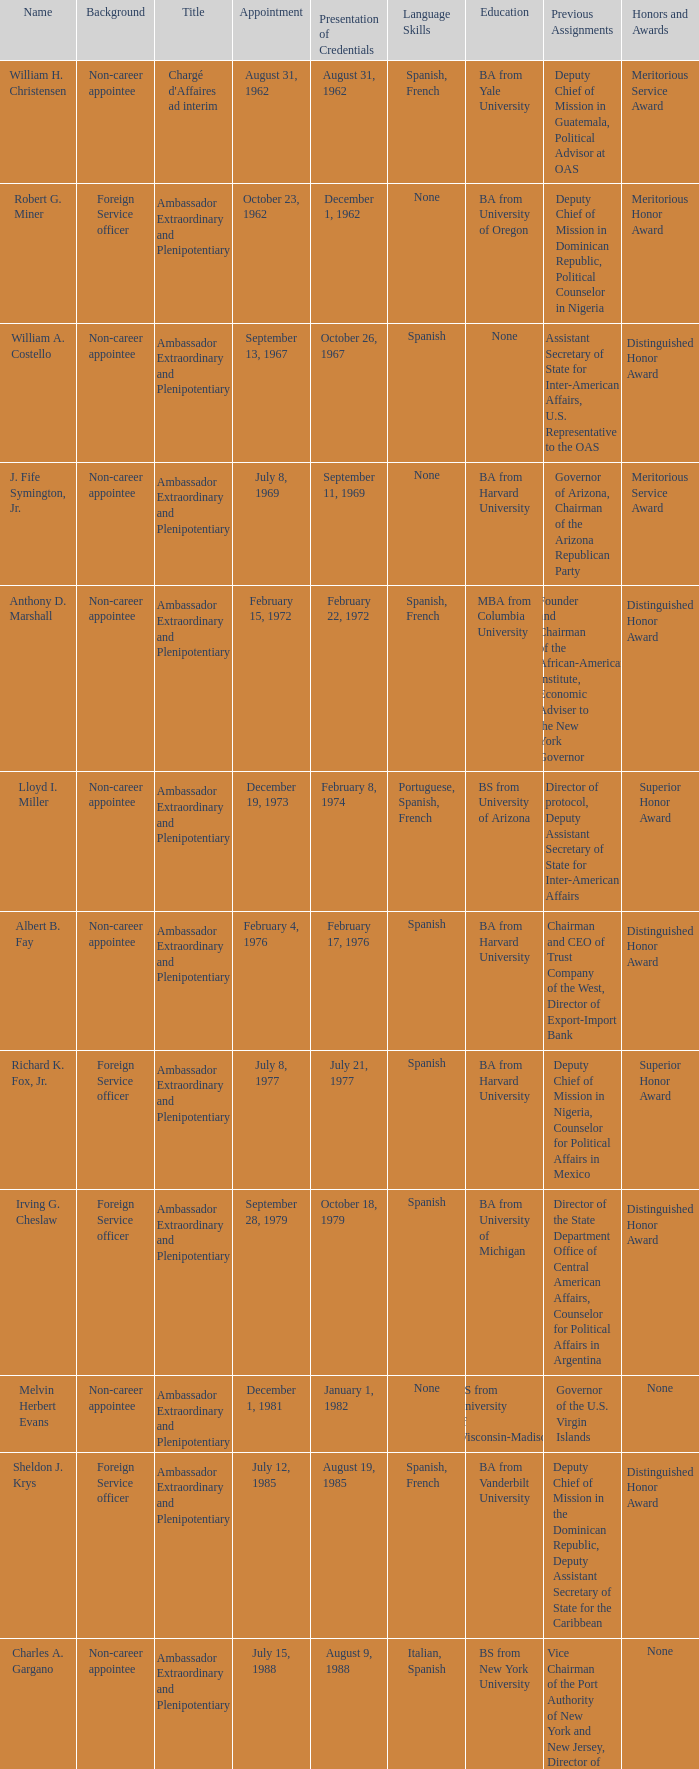Who presented their credentials at an unknown date? Margaret B. Diop. Would you mind parsing the complete table? {'header': ['Name', 'Background', 'Title', 'Appointment', 'Presentation of Credentials', 'Language Skills', 'Education', 'Previous Assignments', 'Honors and Awards'], 'rows': [['William H. Christensen', 'Non-career appointee', "Chargé d'Affaires ad interim", 'August 31, 1962', 'August 31, 1962', 'Spanish, French', 'BA from Yale University', 'Deputy Chief of Mission in Guatemala, Political Advisor at OAS', 'Meritorious Service Award'], ['Robert G. Miner', 'Foreign Service officer', 'Ambassador Extraordinary and Plenipotentiary', 'October 23, 1962', 'December 1, 1962', 'None', 'BA from University of Oregon', 'Deputy Chief of Mission in Dominican Republic, Political Counselor in Nigeria', 'Meritorious Honor Award'], ['William A. Costello', 'Non-career appointee', 'Ambassador Extraordinary and Plenipotentiary', 'September 13, 1967', 'October 26, 1967', 'Spanish', 'None', 'Assistant Secretary of State for Inter-American Affairs, U.S. Representative to the OAS', 'Distinguished Honor Award'], ['J. Fife Symington, Jr.', 'Non-career appointee', 'Ambassador Extraordinary and Plenipotentiary', 'July 8, 1969', 'September 11, 1969', 'None', 'BA from Harvard University', 'Governor of Arizona, Chairman of the Arizona Republican Party', 'Meritorious Service Award'], ['Anthony D. Marshall', 'Non-career appointee', 'Ambassador Extraordinary and Plenipotentiary', 'February 15, 1972', 'February 22, 1972', 'Spanish, French', 'MBA from Columbia University', 'Founder and Chairman of the African-American Institute, Economic Adviser to the New York Governor', 'Distinguished Honor Award'], ['Lloyd I. Miller', 'Non-career appointee', 'Ambassador Extraordinary and Plenipotentiary', 'December 19, 1973', 'February 8, 1974', 'Portuguese, Spanish, French', 'BS from University of Arizona', 'Director of protocol, Deputy Assistant Secretary of State for Inter-American Affairs', 'Superior Honor Award'], ['Albert B. Fay', 'Non-career appointee', 'Ambassador Extraordinary and Plenipotentiary', 'February 4, 1976', 'February 17, 1976', 'Spanish', 'BA from Harvard University', 'Chairman and CEO of Trust Company of the West, Director of Export-Import Bank', 'Distinguished Honor Award'], ['Richard K. Fox, Jr.', 'Foreign Service officer', 'Ambassador Extraordinary and Plenipotentiary', 'July 8, 1977', 'July 21, 1977', 'Spanish', 'BA from Harvard University', 'Deputy Chief of Mission in Nigeria, Counselor for Political Affairs in Mexico', 'Superior Honor Award'], ['Irving G. Cheslaw', 'Foreign Service officer', 'Ambassador Extraordinary and Plenipotentiary', 'September 28, 1979', 'October 18, 1979', 'Spanish', 'BA from University of Michigan', 'Director of the State Department Office of Central American Affairs, Counselor for Political Affairs in Argentina', 'Distinguished Honor Award'], ['Melvin Herbert Evans', 'Non-career appointee', 'Ambassador Extraordinary and Plenipotentiary', 'December 1, 1981', 'January 1, 1982', 'None', 'BS from University of Wisconsin-Madison', 'Governor of the U.S. Virgin Islands', 'None'], ['Sheldon J. Krys', 'Foreign Service officer', 'Ambassador Extraordinary and Plenipotentiary', 'July 12, 1985', 'August 19, 1985', 'Spanish, French', 'BA from Vanderbilt University', 'Deputy Chief of Mission in the Dominican Republic, Deputy Assistant Secretary of State for the Caribbean', 'Distinguished Honor Award'], ['Charles A. Gargano', 'Non-career appointee', 'Ambassador Extraordinary and Plenipotentiary', 'July 15, 1988', 'August 9, 1988', 'Italian, Spanish', 'BS from New York University', 'Vice Chairman of the Port Authority of New York and New Jersey, Director of the Metropolitan Transportation Authority', 'None'], ['Sally G. Cowal', 'Foreign Service officer', 'Ambassador Extraordinary and Plenipotentiary', 'August 2, 1991', 'August 27, 1991', 'Spanish, Italian', 'BA from University of Michigan', 'Deputy Assistant Administrator for Latin America and the Caribbean at USAID, Deputy Chief of Mission in Panama', 'Distinguished Honor Award'], ['Brian J. Donnelly', 'Non-career appointee', 'Ambassador Extraordinary and Plenipotentiary', 'July 5, 1994', 'September 5, 1994', 'None', 'BA from Middlebury College, MBA from Stanford University', "Chairman of Value America, President of Ben & Jerry's Homemade, Inc.", 'None'], ['Edward E. Shumaker III', 'Non-career appointee', 'Ambassador Extraordinary and Plenipotentiary', 'October 24, 1997', 'January 13, 1998', 'Spanish', 'BA from University of Virginia', 'Assistant U.S. Trade Representative for Mexico and Canada, Executive Director of Republican National Committee', 'Distinguished Honor Award'], ['Roy L. Austin', 'Non-career appointee', 'Ambassador Extraordinary and Plenipotentiary', 'October 1, 2001', 'December 6, 2001', 'Spanish, French', 'BS from University of Michigan, JD from DePaul University College of Law', 'Partner at Quarles & Brady, LLP, Associate Counsel to U.S. President George H.W. Bush', 'None '], ['Beatrice Wilkinson Welters', 'Non-career appointee', 'Ambassador Extraordinary and Plenipotentiary', 'April 27, 2010', '2010', 'French, Haitian Creole', 'BA from Manhattanville College, MA from New York University', 'Executive Vice President of the AnBryce Foundation, U.S. Ambassador to Trinidad and Tobago', 'None'], ['Margaret B. Diop', 'Foreign Service officer', "Chargé d'Affaires ad interim", 'October 2012', 'Unknown', 'French', 'BA from University of California, Berkeley', 'Political Counselor at U.S. Embassy in Senegal, Director of the Office of Central African Affairs', 'Superior Honor Award']]} 